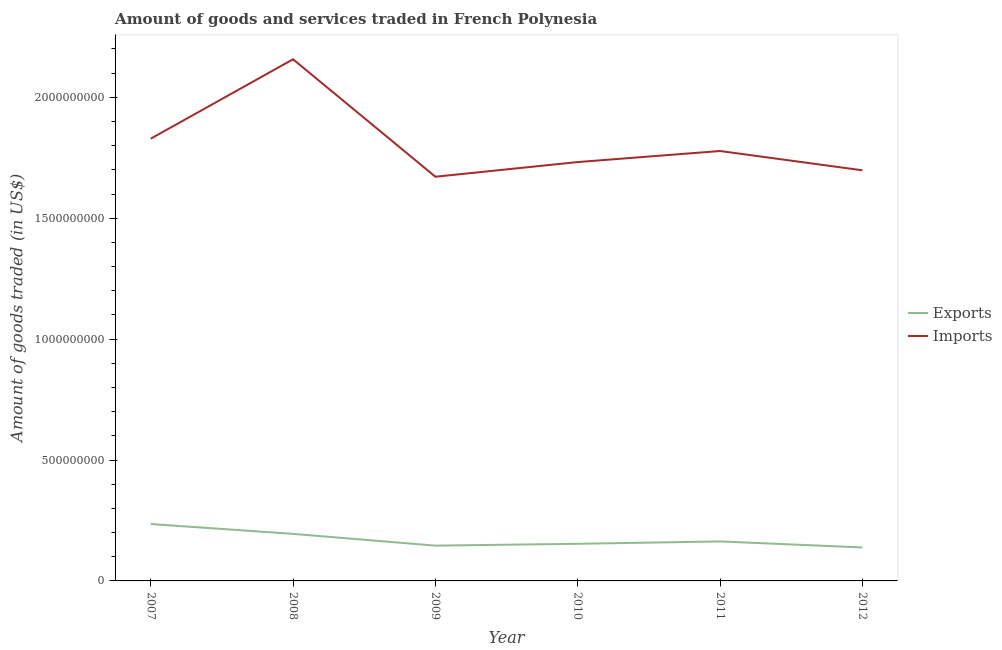How many different coloured lines are there?
Make the answer very short. 2. What is the amount of goods imported in 2010?
Make the answer very short. 1.73e+09. Across all years, what is the maximum amount of goods imported?
Keep it short and to the point. 2.16e+09. Across all years, what is the minimum amount of goods exported?
Provide a succinct answer. 1.38e+08. What is the total amount of goods imported in the graph?
Give a very brief answer. 1.09e+1. What is the difference between the amount of goods exported in 2009 and that in 2010?
Offer a terse response. -7.60e+06. What is the difference between the amount of goods imported in 2011 and the amount of goods exported in 2009?
Offer a terse response. 1.63e+09. What is the average amount of goods exported per year?
Make the answer very short. 1.72e+08. In the year 2007, what is the difference between the amount of goods exported and amount of goods imported?
Make the answer very short. -1.59e+09. What is the ratio of the amount of goods imported in 2009 to that in 2010?
Your answer should be very brief. 0.97. Is the amount of goods imported in 2008 less than that in 2010?
Provide a succinct answer. No. What is the difference between the highest and the second highest amount of goods imported?
Your response must be concise. 3.28e+08. What is the difference between the highest and the lowest amount of goods exported?
Your answer should be very brief. 9.68e+07. In how many years, is the amount of goods imported greater than the average amount of goods imported taken over all years?
Your response must be concise. 2. Is the sum of the amount of goods imported in 2010 and 2012 greater than the maximum amount of goods exported across all years?
Keep it short and to the point. Yes. Does the amount of goods exported monotonically increase over the years?
Keep it short and to the point. No. Are the values on the major ticks of Y-axis written in scientific E-notation?
Your answer should be compact. No. Does the graph contain grids?
Make the answer very short. No. Where does the legend appear in the graph?
Provide a short and direct response. Center right. What is the title of the graph?
Make the answer very short. Amount of goods and services traded in French Polynesia. What is the label or title of the Y-axis?
Provide a short and direct response. Amount of goods traded (in US$). What is the Amount of goods traded (in US$) of Exports in 2007?
Make the answer very short. 2.35e+08. What is the Amount of goods traded (in US$) in Imports in 2007?
Make the answer very short. 1.83e+09. What is the Amount of goods traded (in US$) in Exports in 2008?
Provide a succinct answer. 1.95e+08. What is the Amount of goods traded (in US$) in Imports in 2008?
Offer a terse response. 2.16e+09. What is the Amount of goods traded (in US$) of Exports in 2009?
Your answer should be very brief. 1.46e+08. What is the Amount of goods traded (in US$) of Imports in 2009?
Your answer should be very brief. 1.67e+09. What is the Amount of goods traded (in US$) in Exports in 2010?
Offer a terse response. 1.54e+08. What is the Amount of goods traded (in US$) of Imports in 2010?
Keep it short and to the point. 1.73e+09. What is the Amount of goods traded (in US$) in Exports in 2011?
Your answer should be very brief. 1.63e+08. What is the Amount of goods traded (in US$) of Imports in 2011?
Make the answer very short. 1.78e+09. What is the Amount of goods traded (in US$) in Exports in 2012?
Your answer should be compact. 1.38e+08. What is the Amount of goods traded (in US$) of Imports in 2012?
Keep it short and to the point. 1.70e+09. Across all years, what is the maximum Amount of goods traded (in US$) of Exports?
Provide a short and direct response. 2.35e+08. Across all years, what is the maximum Amount of goods traded (in US$) in Imports?
Provide a short and direct response. 2.16e+09. Across all years, what is the minimum Amount of goods traded (in US$) of Exports?
Ensure brevity in your answer.  1.38e+08. Across all years, what is the minimum Amount of goods traded (in US$) in Imports?
Keep it short and to the point. 1.67e+09. What is the total Amount of goods traded (in US$) in Exports in the graph?
Make the answer very short. 1.03e+09. What is the total Amount of goods traded (in US$) in Imports in the graph?
Your response must be concise. 1.09e+1. What is the difference between the Amount of goods traded (in US$) in Exports in 2007 and that in 2008?
Your answer should be very brief. 4.07e+07. What is the difference between the Amount of goods traded (in US$) of Imports in 2007 and that in 2008?
Your response must be concise. -3.28e+08. What is the difference between the Amount of goods traded (in US$) of Exports in 2007 and that in 2009?
Give a very brief answer. 8.93e+07. What is the difference between the Amount of goods traded (in US$) in Imports in 2007 and that in 2009?
Provide a short and direct response. 1.57e+08. What is the difference between the Amount of goods traded (in US$) of Exports in 2007 and that in 2010?
Ensure brevity in your answer.  8.17e+07. What is the difference between the Amount of goods traded (in US$) of Imports in 2007 and that in 2010?
Give a very brief answer. 9.67e+07. What is the difference between the Amount of goods traded (in US$) of Exports in 2007 and that in 2011?
Give a very brief answer. 7.20e+07. What is the difference between the Amount of goods traded (in US$) in Imports in 2007 and that in 2011?
Offer a very short reply. 5.10e+07. What is the difference between the Amount of goods traded (in US$) of Exports in 2007 and that in 2012?
Offer a very short reply. 9.68e+07. What is the difference between the Amount of goods traded (in US$) in Imports in 2007 and that in 2012?
Your answer should be very brief. 1.31e+08. What is the difference between the Amount of goods traded (in US$) in Exports in 2008 and that in 2009?
Your response must be concise. 4.86e+07. What is the difference between the Amount of goods traded (in US$) in Imports in 2008 and that in 2009?
Keep it short and to the point. 4.86e+08. What is the difference between the Amount of goods traded (in US$) in Exports in 2008 and that in 2010?
Your answer should be very brief. 4.10e+07. What is the difference between the Amount of goods traded (in US$) of Imports in 2008 and that in 2010?
Your answer should be compact. 4.25e+08. What is the difference between the Amount of goods traded (in US$) in Exports in 2008 and that in 2011?
Your answer should be compact. 3.13e+07. What is the difference between the Amount of goods traded (in US$) of Imports in 2008 and that in 2011?
Make the answer very short. 3.79e+08. What is the difference between the Amount of goods traded (in US$) of Exports in 2008 and that in 2012?
Offer a very short reply. 5.61e+07. What is the difference between the Amount of goods traded (in US$) in Imports in 2008 and that in 2012?
Ensure brevity in your answer.  4.59e+08. What is the difference between the Amount of goods traded (in US$) of Exports in 2009 and that in 2010?
Ensure brevity in your answer.  -7.60e+06. What is the difference between the Amount of goods traded (in US$) of Imports in 2009 and that in 2010?
Your answer should be very brief. -6.06e+07. What is the difference between the Amount of goods traded (in US$) in Exports in 2009 and that in 2011?
Provide a succinct answer. -1.73e+07. What is the difference between the Amount of goods traded (in US$) in Imports in 2009 and that in 2011?
Your answer should be very brief. -1.06e+08. What is the difference between the Amount of goods traded (in US$) in Exports in 2009 and that in 2012?
Keep it short and to the point. 7.45e+06. What is the difference between the Amount of goods traded (in US$) of Imports in 2009 and that in 2012?
Make the answer very short. -2.66e+07. What is the difference between the Amount of goods traded (in US$) of Exports in 2010 and that in 2011?
Your answer should be very brief. -9.71e+06. What is the difference between the Amount of goods traded (in US$) in Imports in 2010 and that in 2011?
Give a very brief answer. -4.57e+07. What is the difference between the Amount of goods traded (in US$) in Exports in 2010 and that in 2012?
Offer a terse response. 1.50e+07. What is the difference between the Amount of goods traded (in US$) in Imports in 2010 and that in 2012?
Make the answer very short. 3.40e+07. What is the difference between the Amount of goods traded (in US$) in Exports in 2011 and that in 2012?
Your answer should be very brief. 2.48e+07. What is the difference between the Amount of goods traded (in US$) in Imports in 2011 and that in 2012?
Your response must be concise. 7.98e+07. What is the difference between the Amount of goods traded (in US$) in Exports in 2007 and the Amount of goods traded (in US$) in Imports in 2008?
Keep it short and to the point. -1.92e+09. What is the difference between the Amount of goods traded (in US$) of Exports in 2007 and the Amount of goods traded (in US$) of Imports in 2009?
Offer a very short reply. -1.44e+09. What is the difference between the Amount of goods traded (in US$) in Exports in 2007 and the Amount of goods traded (in US$) in Imports in 2010?
Offer a terse response. -1.50e+09. What is the difference between the Amount of goods traded (in US$) in Exports in 2007 and the Amount of goods traded (in US$) in Imports in 2011?
Ensure brevity in your answer.  -1.54e+09. What is the difference between the Amount of goods traded (in US$) of Exports in 2007 and the Amount of goods traded (in US$) of Imports in 2012?
Make the answer very short. -1.46e+09. What is the difference between the Amount of goods traded (in US$) of Exports in 2008 and the Amount of goods traded (in US$) of Imports in 2009?
Make the answer very short. -1.48e+09. What is the difference between the Amount of goods traded (in US$) in Exports in 2008 and the Amount of goods traded (in US$) in Imports in 2010?
Provide a short and direct response. -1.54e+09. What is the difference between the Amount of goods traded (in US$) of Exports in 2008 and the Amount of goods traded (in US$) of Imports in 2011?
Your response must be concise. -1.58e+09. What is the difference between the Amount of goods traded (in US$) in Exports in 2008 and the Amount of goods traded (in US$) in Imports in 2012?
Provide a short and direct response. -1.50e+09. What is the difference between the Amount of goods traded (in US$) in Exports in 2009 and the Amount of goods traded (in US$) in Imports in 2010?
Provide a succinct answer. -1.59e+09. What is the difference between the Amount of goods traded (in US$) of Exports in 2009 and the Amount of goods traded (in US$) of Imports in 2011?
Make the answer very short. -1.63e+09. What is the difference between the Amount of goods traded (in US$) of Exports in 2009 and the Amount of goods traded (in US$) of Imports in 2012?
Your answer should be compact. -1.55e+09. What is the difference between the Amount of goods traded (in US$) in Exports in 2010 and the Amount of goods traded (in US$) in Imports in 2011?
Provide a succinct answer. -1.62e+09. What is the difference between the Amount of goods traded (in US$) of Exports in 2010 and the Amount of goods traded (in US$) of Imports in 2012?
Give a very brief answer. -1.54e+09. What is the difference between the Amount of goods traded (in US$) of Exports in 2011 and the Amount of goods traded (in US$) of Imports in 2012?
Offer a very short reply. -1.53e+09. What is the average Amount of goods traded (in US$) of Exports per year?
Give a very brief answer. 1.72e+08. What is the average Amount of goods traded (in US$) in Imports per year?
Offer a very short reply. 1.81e+09. In the year 2007, what is the difference between the Amount of goods traded (in US$) in Exports and Amount of goods traded (in US$) in Imports?
Keep it short and to the point. -1.59e+09. In the year 2008, what is the difference between the Amount of goods traded (in US$) in Exports and Amount of goods traded (in US$) in Imports?
Offer a very short reply. -1.96e+09. In the year 2009, what is the difference between the Amount of goods traded (in US$) in Exports and Amount of goods traded (in US$) in Imports?
Keep it short and to the point. -1.53e+09. In the year 2010, what is the difference between the Amount of goods traded (in US$) of Exports and Amount of goods traded (in US$) of Imports?
Your response must be concise. -1.58e+09. In the year 2011, what is the difference between the Amount of goods traded (in US$) of Exports and Amount of goods traded (in US$) of Imports?
Give a very brief answer. -1.61e+09. In the year 2012, what is the difference between the Amount of goods traded (in US$) of Exports and Amount of goods traded (in US$) of Imports?
Give a very brief answer. -1.56e+09. What is the ratio of the Amount of goods traded (in US$) of Exports in 2007 to that in 2008?
Give a very brief answer. 1.21. What is the ratio of the Amount of goods traded (in US$) in Imports in 2007 to that in 2008?
Keep it short and to the point. 0.85. What is the ratio of the Amount of goods traded (in US$) in Exports in 2007 to that in 2009?
Offer a terse response. 1.61. What is the ratio of the Amount of goods traded (in US$) of Imports in 2007 to that in 2009?
Provide a short and direct response. 1.09. What is the ratio of the Amount of goods traded (in US$) of Exports in 2007 to that in 2010?
Your answer should be compact. 1.53. What is the ratio of the Amount of goods traded (in US$) of Imports in 2007 to that in 2010?
Your answer should be very brief. 1.06. What is the ratio of the Amount of goods traded (in US$) of Exports in 2007 to that in 2011?
Provide a succinct answer. 1.44. What is the ratio of the Amount of goods traded (in US$) in Imports in 2007 to that in 2011?
Offer a very short reply. 1.03. What is the ratio of the Amount of goods traded (in US$) in Exports in 2007 to that in 2012?
Provide a succinct answer. 1.7. What is the ratio of the Amount of goods traded (in US$) in Imports in 2007 to that in 2012?
Your answer should be compact. 1.08. What is the ratio of the Amount of goods traded (in US$) in Exports in 2008 to that in 2009?
Your answer should be compact. 1.33. What is the ratio of the Amount of goods traded (in US$) in Imports in 2008 to that in 2009?
Provide a short and direct response. 1.29. What is the ratio of the Amount of goods traded (in US$) in Exports in 2008 to that in 2010?
Offer a very short reply. 1.27. What is the ratio of the Amount of goods traded (in US$) in Imports in 2008 to that in 2010?
Offer a terse response. 1.25. What is the ratio of the Amount of goods traded (in US$) in Exports in 2008 to that in 2011?
Your answer should be compact. 1.19. What is the ratio of the Amount of goods traded (in US$) of Imports in 2008 to that in 2011?
Your response must be concise. 1.21. What is the ratio of the Amount of goods traded (in US$) in Exports in 2008 to that in 2012?
Keep it short and to the point. 1.4. What is the ratio of the Amount of goods traded (in US$) of Imports in 2008 to that in 2012?
Your answer should be compact. 1.27. What is the ratio of the Amount of goods traded (in US$) of Exports in 2009 to that in 2010?
Make the answer very short. 0.95. What is the ratio of the Amount of goods traded (in US$) in Imports in 2009 to that in 2010?
Offer a very short reply. 0.96. What is the ratio of the Amount of goods traded (in US$) in Exports in 2009 to that in 2011?
Provide a succinct answer. 0.89. What is the ratio of the Amount of goods traded (in US$) of Imports in 2009 to that in 2011?
Your response must be concise. 0.94. What is the ratio of the Amount of goods traded (in US$) in Exports in 2009 to that in 2012?
Your response must be concise. 1.05. What is the ratio of the Amount of goods traded (in US$) in Imports in 2009 to that in 2012?
Provide a succinct answer. 0.98. What is the ratio of the Amount of goods traded (in US$) in Exports in 2010 to that in 2011?
Give a very brief answer. 0.94. What is the ratio of the Amount of goods traded (in US$) in Imports in 2010 to that in 2011?
Provide a short and direct response. 0.97. What is the ratio of the Amount of goods traded (in US$) of Exports in 2010 to that in 2012?
Offer a very short reply. 1.11. What is the ratio of the Amount of goods traded (in US$) of Exports in 2011 to that in 2012?
Offer a terse response. 1.18. What is the ratio of the Amount of goods traded (in US$) of Imports in 2011 to that in 2012?
Provide a succinct answer. 1.05. What is the difference between the highest and the second highest Amount of goods traded (in US$) of Exports?
Your response must be concise. 4.07e+07. What is the difference between the highest and the second highest Amount of goods traded (in US$) in Imports?
Your answer should be compact. 3.28e+08. What is the difference between the highest and the lowest Amount of goods traded (in US$) of Exports?
Keep it short and to the point. 9.68e+07. What is the difference between the highest and the lowest Amount of goods traded (in US$) in Imports?
Give a very brief answer. 4.86e+08. 